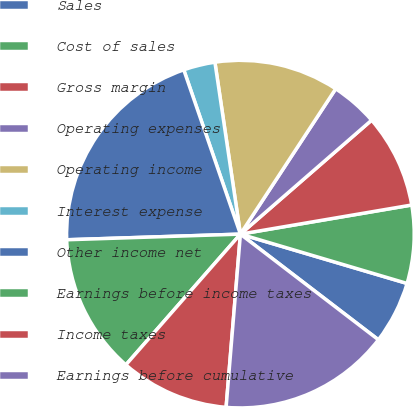<chart> <loc_0><loc_0><loc_500><loc_500><pie_chart><fcel>Sales<fcel>Cost of sales<fcel>Gross margin<fcel>Operating expenses<fcel>Operating income<fcel>Interest expense<fcel>Other income net<fcel>Earnings before income taxes<fcel>Income taxes<fcel>Earnings before cumulative<nl><fcel>5.82%<fcel>7.26%<fcel>8.7%<fcel>4.38%<fcel>11.58%<fcel>2.94%<fcel>20.23%<fcel>13.03%<fcel>10.14%<fcel>15.91%<nl></chart> 